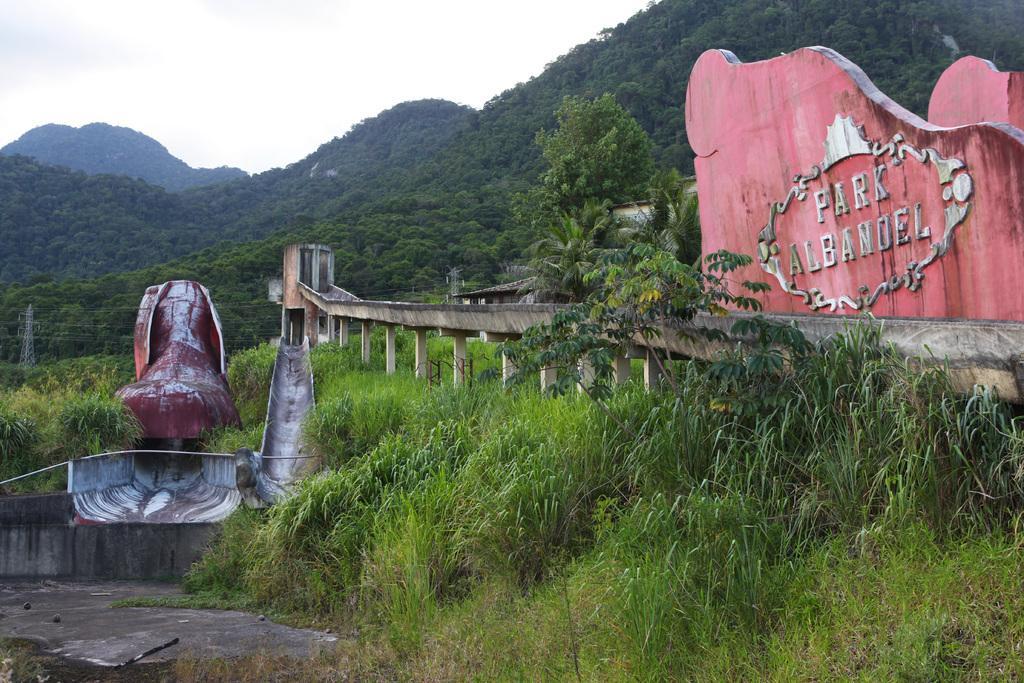Could you give a brief overview of what you see in this image? This looks like a name board with the letters on it. These are the plants and the grass. I can see the trees. This looks like a slider. I can see the hills. On the right side of the image, that looks like a transmission tower with the current wires. 